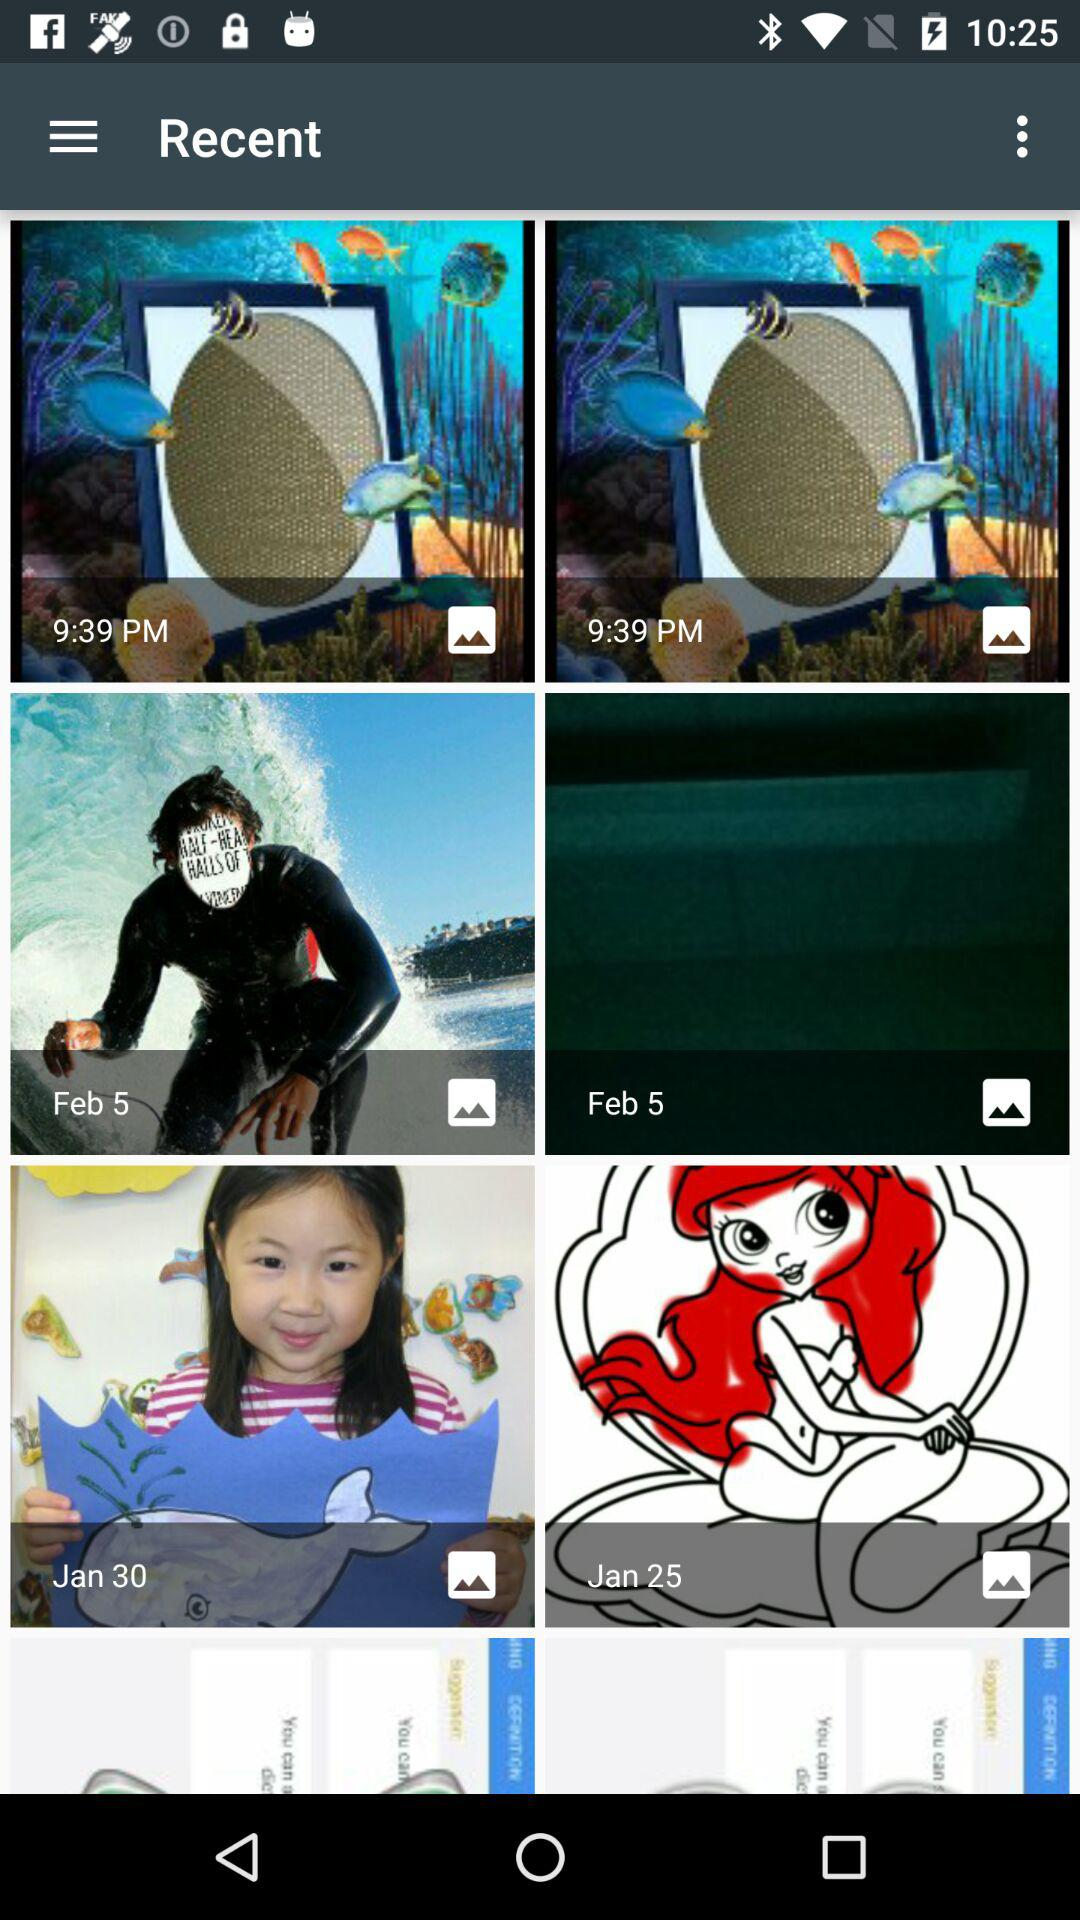When was the first image added? The first image was added at 9:39 PM. 